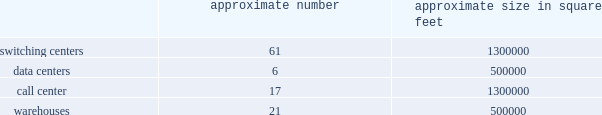In particular , we have received commitments for $ 30.0 billion in debt financing to fund the transactions which is comprised of ( i ) a $ 4.0 billion secured revolving credit facility , ( ii ) a $ 7.0 billion term loan credit facility and ( iii ) a $ 19.0 billion secured bridge loan facility .
Our reliance on the financing from the $ 19.0 billion secured bridge loan facility commitment is intended to be reduced through one or more secured note offerings or other long-term financings prior to the merger closing .
However , there can be no assurance that we will be able to issue any such secured notes or other long-term financings on terms we find acceptable or at all , especially in light of the recent debt market volatility , in which case we may have to exercise some or all of the commitments under the secured bridge facility to fund the transactions .
Accordingly , the costs of financing for the transactions may be higher than expected .
Credit rating downgrades could adversely affect the businesses , cash flows , financial condition and operating results of t-mobile and , following the transactions , the combined company .
Credit ratings impact the cost and availability of future borrowings , and , as a result , cost of capital .
Our current ratings reflect each rating agency 2019s opinion of our financial strength , operating performance and ability to meet our debt obligations or , following the completion of the transactions , obligations to the combined company 2019s obligors .
Each rating agency reviews these ratings periodically and there can be no assurance that such ratings will be maintained in the future .
A downgrade in the rating of us and/or sprint could adversely affect the businesses , cash flows , financial condition and operating results of t- mobile and , following the transactions , the combined company .
We have incurred , and will incur , direct and indirect costs as a result of the transactions .
We have incurred , and will incur , substantial expenses in connection with and as a result of completing the transactions , and over a period of time following the completion of the transactions , the combined company also expects to incur substantial expenses in connection with integrating and coordinating our and sprint 2019s businesses , operations , policies and procedures .
A portion of the transaction costs related to the transactions will be incurred regardless of whether the transactions are completed .
While we have assumed that a certain level of transaction expenses will be incurred , factors beyond our control could affect the total amount or the timing of these expenses .
Many of the expenses that will be incurred , by their nature , are difficult to estimate accurately .
These expenses will exceed the costs historically borne by us .
These costs could adversely affect our financial condition and results of operations prior to the transactions and the financial condition and results of operations of the combined company following the transactions .
Item 1b .
Unresolved staff comments item 2 .
Properties as of december 31 , 2018 , our significant properties that we primarily lease and use in connection with switching centers , data centers , call centers and warehouses were as follows: .
As of december 31 , 2018 , we primarily leased : 2022 approximately 64000 macro towers and 21000 distributed antenna system and small cell sites .
2022 approximately 2200 t-mobile and metro by t-mobile retail locations , including stores and kiosks ranging in size from approximately 100 square feet to 17000 square feet .
2022 office space totaling approximately 1000000 square feet for our corporate headquarters in bellevue , washington .
In january 2019 , we executed leases totaling approximately 170000 additional square feet for our corporate headquarters .
We use these offices for engineering and administrative purposes .
2022 office space throughout the u.s. , totaling approximately 1700000 square feet , for use by our regional offices primarily for administrative , engineering and sales purposes. .
What was the average size of the 61 switching centers in square feet? 
Rationale: the average square feet is the total square feet divide by the number of locations
Computations: (1300000 / 61)
Answer: 21311.47541. 